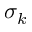<formula> <loc_0><loc_0><loc_500><loc_500>\sigma _ { k }</formula> 